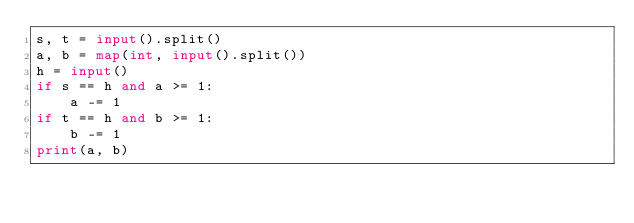<code> <loc_0><loc_0><loc_500><loc_500><_Python_>s, t = input().split()
a, b = map(int, input().split())
h = input()
if s == h and a >= 1:
    a -= 1
if t == h and b >= 1:
    b -= 1
print(a, b)</code> 